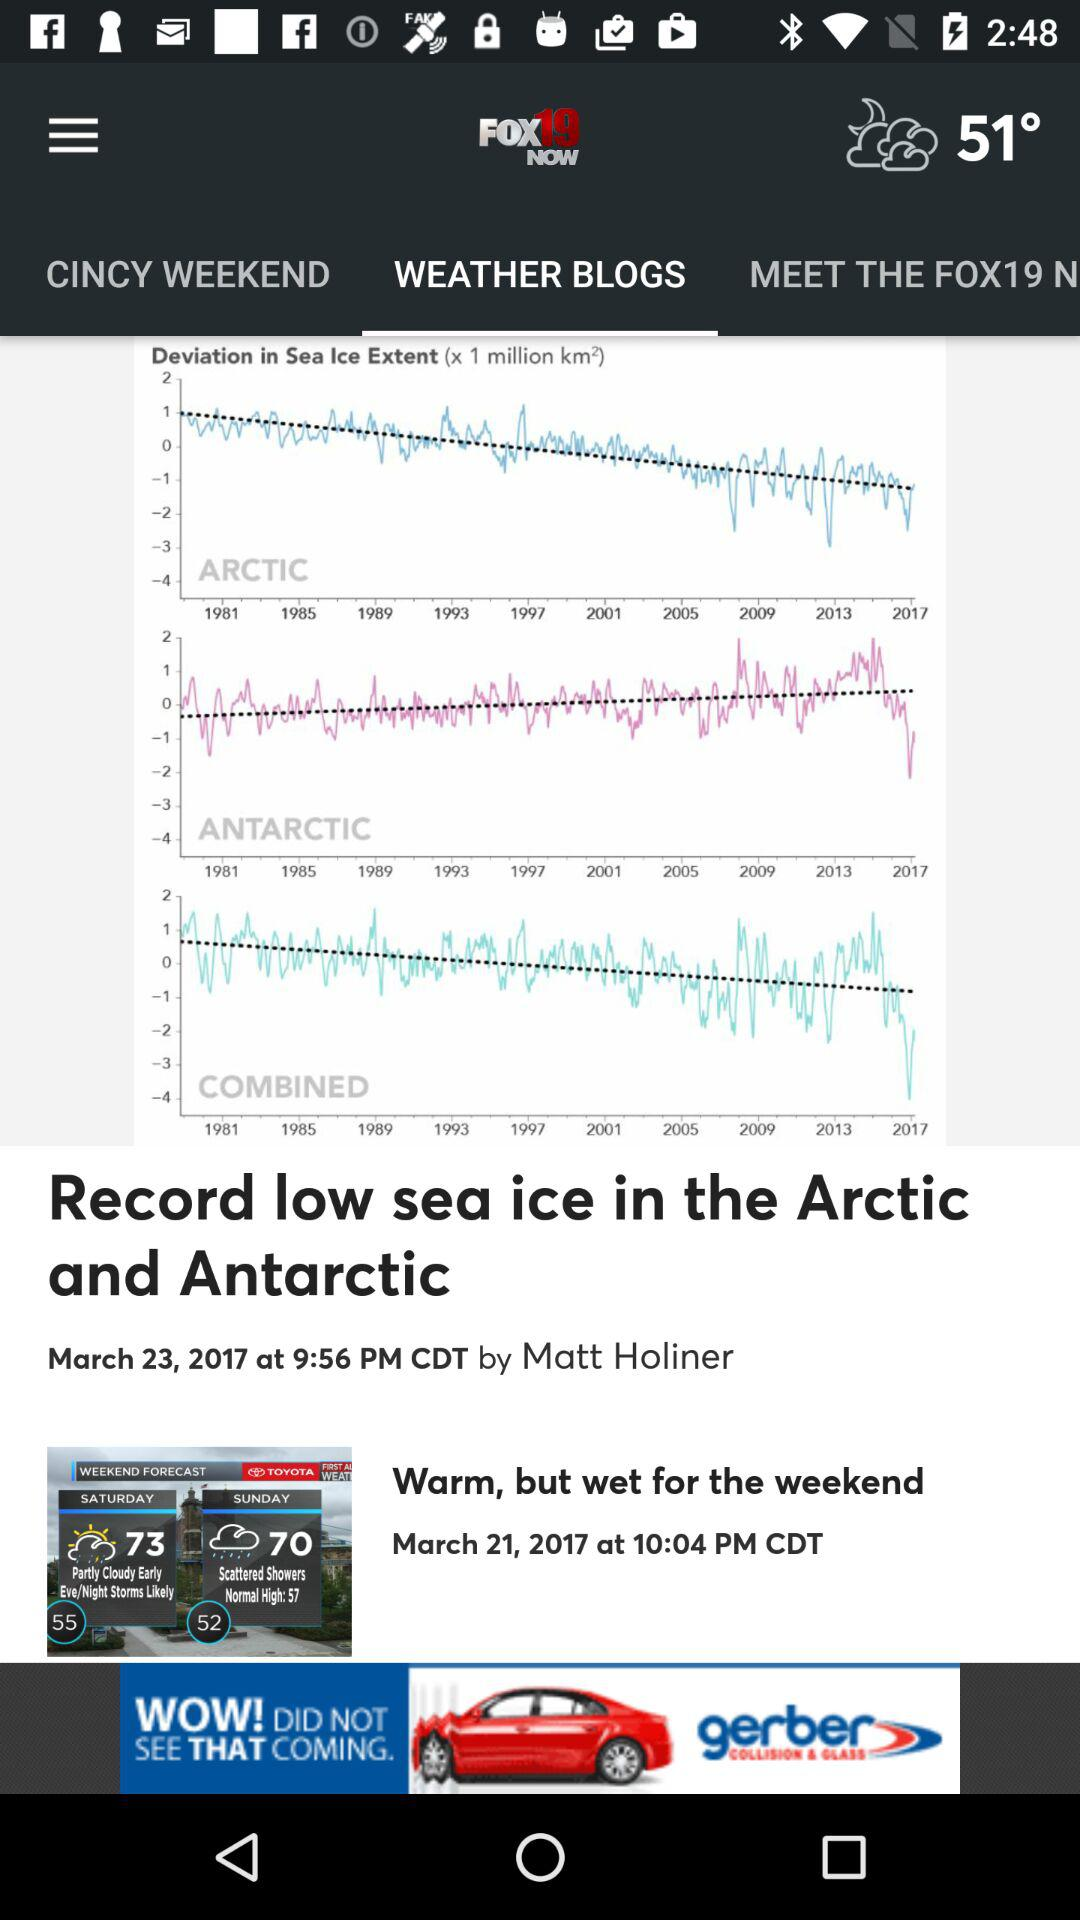What is the date and time the news was posted for "Record low sea ice in the Arctic and Antarctic"? The news is posted on March 23, 2017 at 9:56 PM. 